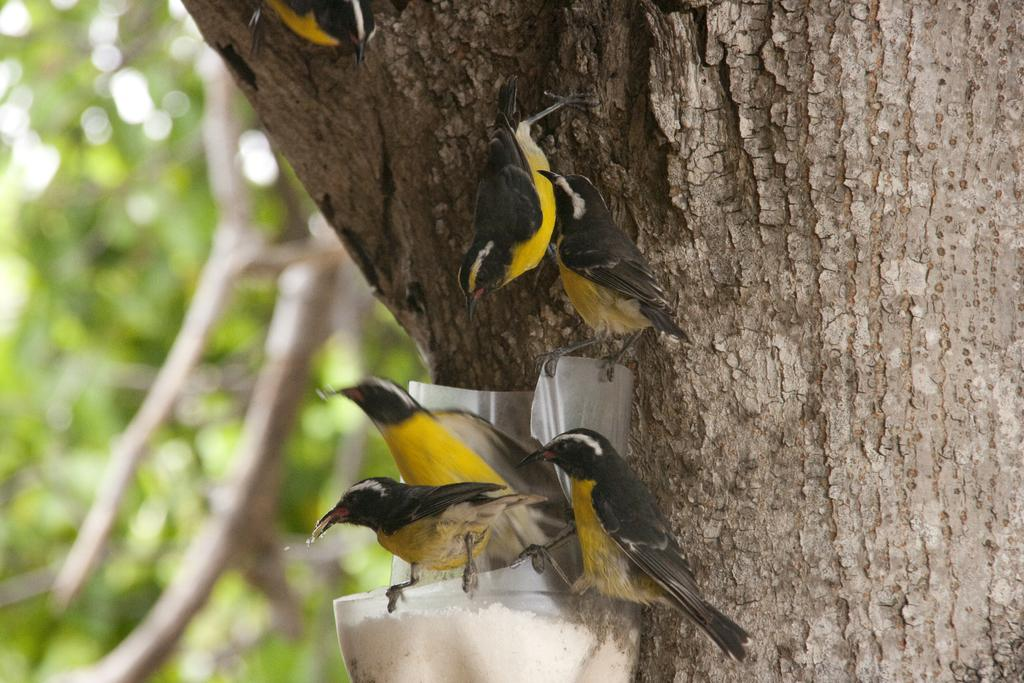What type of animals can be seen in the image? There are birds in the image. What is the main object in the foreground of the image? There is a tree trunk in the image. How would you describe the background of the image? The background of the image is blurred and green. Where is the throne located in the image? There is no throne present in the image. What type of meat can be seen hanging from the tree trunk in the image? There is no meat present in the image; it only features birds and a tree trunk. What color is the orange fruit in the image? There is no orange fruit present in the image. 